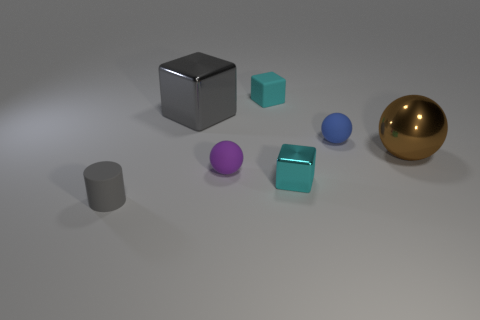What can you infer about the light source in this image? The shadows cast on the ground and the highlights on the objects suggest a single, diffuse light source above the scene, possibly off to the left side. This type of lighting creates soft shadows and indicates an indoor setting, reminiscent of studio lighting. Does the lighting affect the perception of the objects in any way? Yes, the lighting affects the perception of the objects' shapes and textures. For instance, the diffuse light softens the appearance of the objects and enhances the visible textures, bringing out their material qualities. It also highlights the reflective nature of the gold sphere and the blue object, providing a sense of depth and dimension to the scene. 